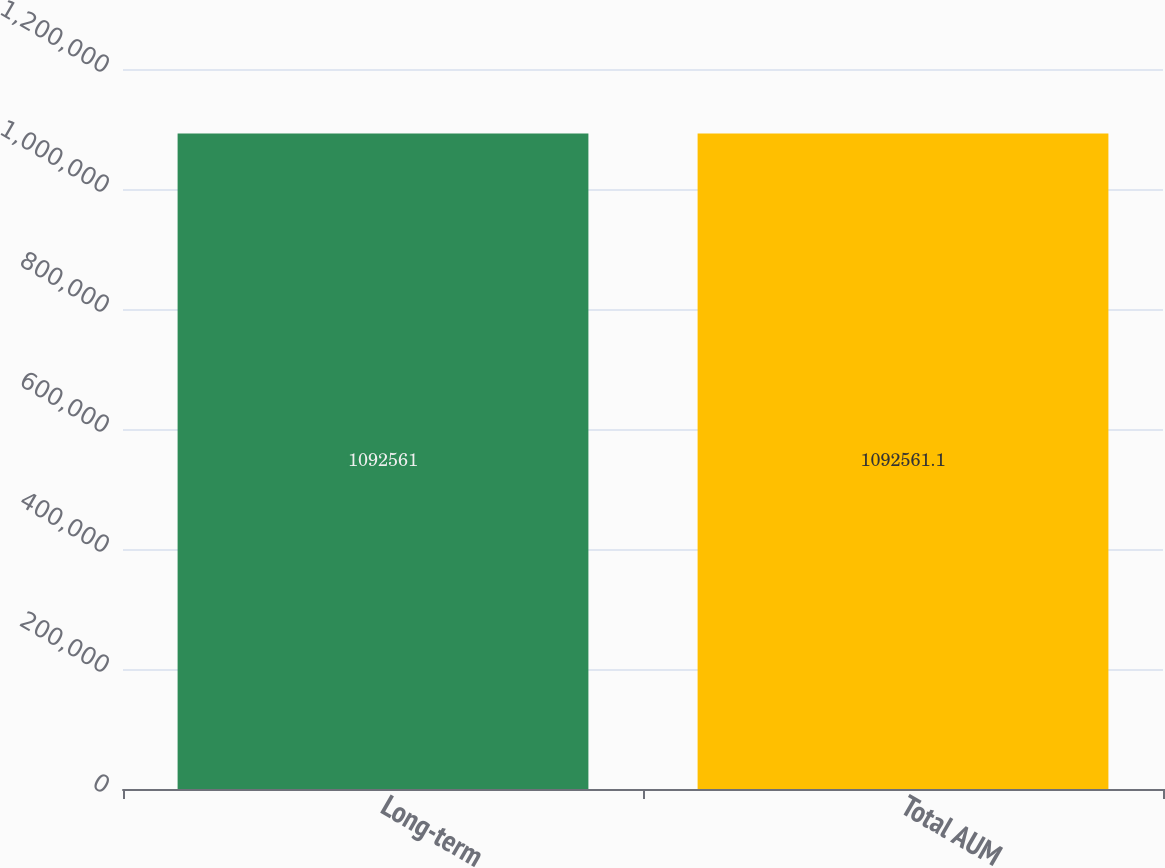<chart> <loc_0><loc_0><loc_500><loc_500><bar_chart><fcel>Long-term<fcel>Total AUM<nl><fcel>1.09256e+06<fcel>1.09256e+06<nl></chart> 